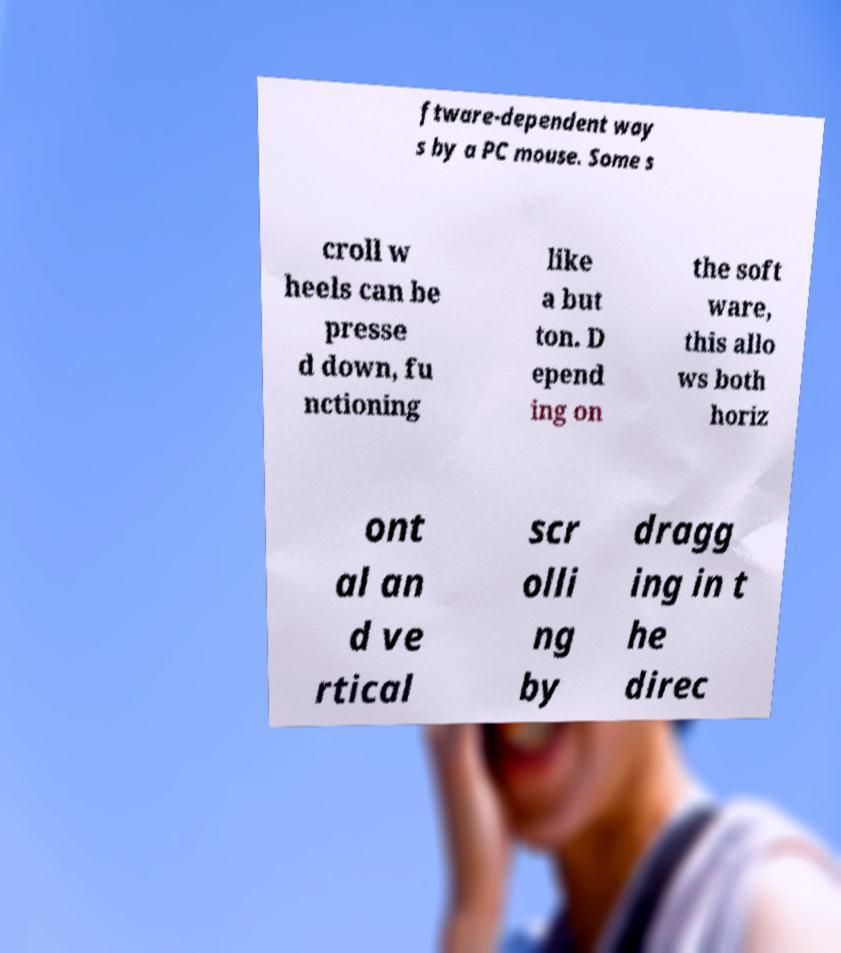Could you extract and type out the text from this image? ftware-dependent way s by a PC mouse. Some s croll w heels can be presse d down, fu nctioning like a but ton. D epend ing on the soft ware, this allo ws both horiz ont al an d ve rtical scr olli ng by dragg ing in t he direc 